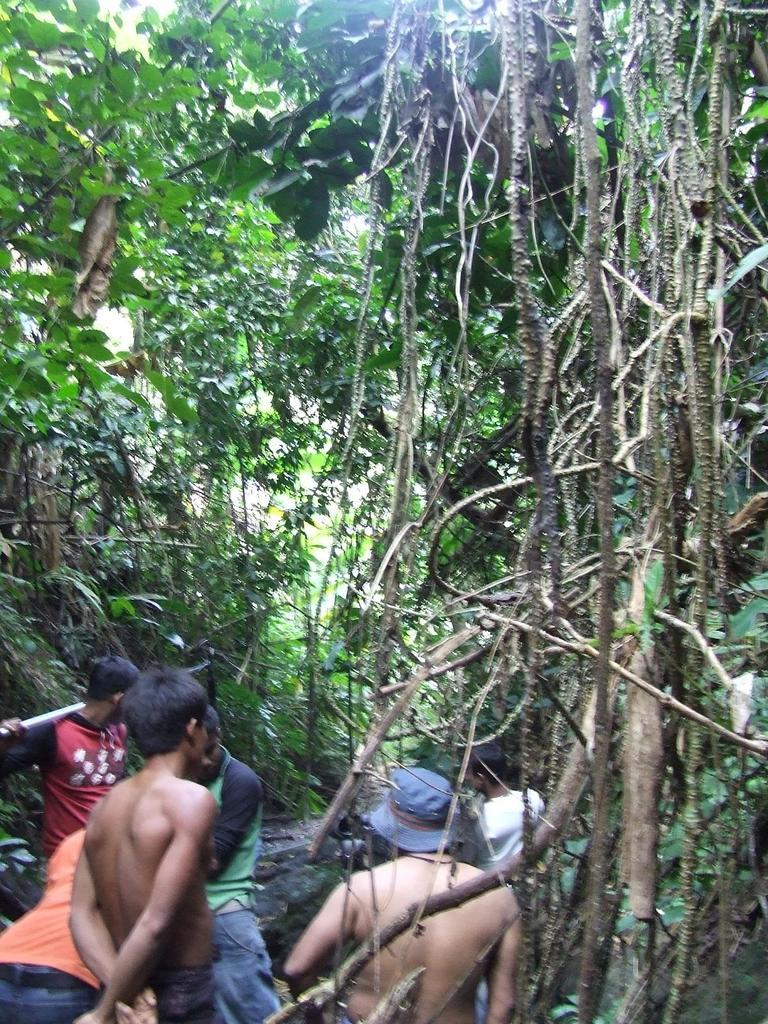What is happening on the left side of the image? There is a group of persons on the left side of the image. What are the persons in the group doing? The group of persons are walking. What can be seen in the middle of the image? There are trees in the middle of the image. How many chairs are visible in the image? There are no chairs present in the image. What type of truck can be seen driving through the trees in the image? There is no truck present in the image; it only features a group of persons walking and trees in the middle. 